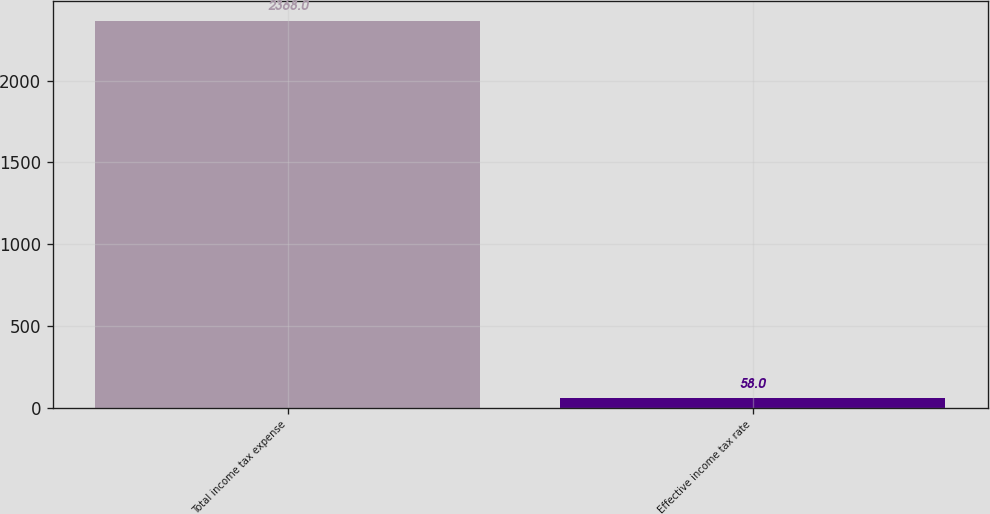Convert chart to OTSL. <chart><loc_0><loc_0><loc_500><loc_500><bar_chart><fcel>Total income tax expense<fcel>Effective income tax rate<nl><fcel>2368<fcel>58<nl></chart> 